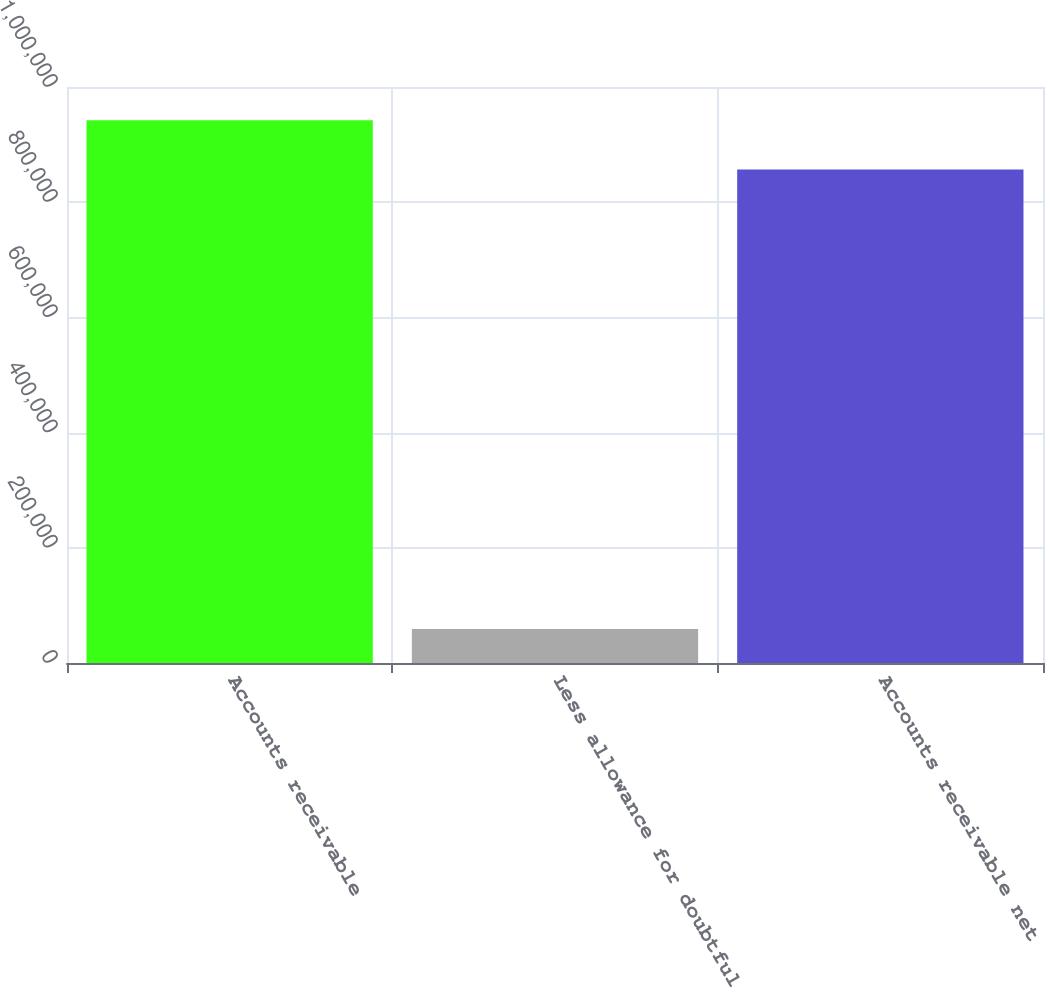Convert chart to OTSL. <chart><loc_0><loc_0><loc_500><loc_500><bar_chart><fcel>Accounts receivable<fcel>Less allowance for doubtful<fcel>Accounts receivable net<nl><fcel>942382<fcel>59113<fcel>856711<nl></chart> 